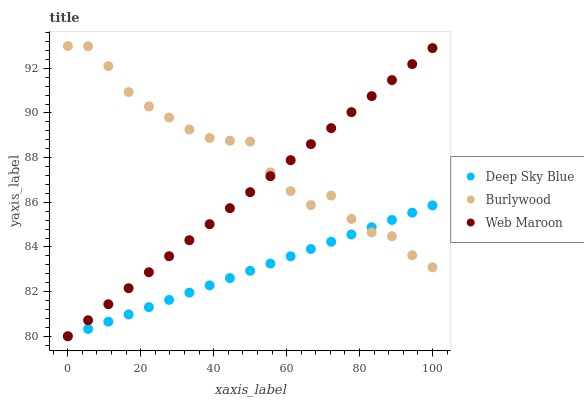Does Deep Sky Blue have the minimum area under the curve?
Answer yes or no. Yes. Does Burlywood have the maximum area under the curve?
Answer yes or no. Yes. Does Web Maroon have the minimum area under the curve?
Answer yes or no. No. Does Web Maroon have the maximum area under the curve?
Answer yes or no. No. Is Deep Sky Blue the smoothest?
Answer yes or no. Yes. Is Burlywood the roughest?
Answer yes or no. Yes. Is Web Maroon the smoothest?
Answer yes or no. No. Is Web Maroon the roughest?
Answer yes or no. No. Does Web Maroon have the lowest value?
Answer yes or no. Yes. Does Burlywood have the highest value?
Answer yes or no. Yes. Does Web Maroon have the highest value?
Answer yes or no. No. Does Web Maroon intersect Deep Sky Blue?
Answer yes or no. Yes. Is Web Maroon less than Deep Sky Blue?
Answer yes or no. No. Is Web Maroon greater than Deep Sky Blue?
Answer yes or no. No. 